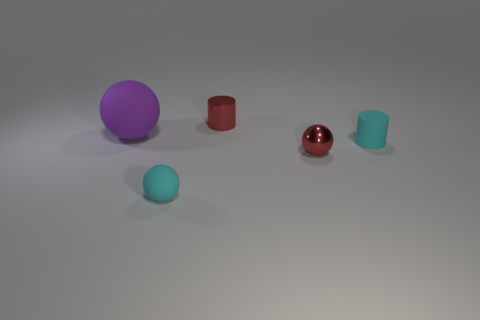Subtract all small metal spheres. How many spheres are left? 2 Add 3 small red balls. How many objects exist? 8 Subtract all brown spheres. Subtract all brown blocks. How many spheres are left? 3 Add 2 tiny red balls. How many tiny red balls exist? 3 Subtract 1 cyan spheres. How many objects are left? 4 Subtract all spheres. How many objects are left? 2 Subtract all tiny red shiny things. Subtract all purple things. How many objects are left? 2 Add 4 large balls. How many large balls are left? 5 